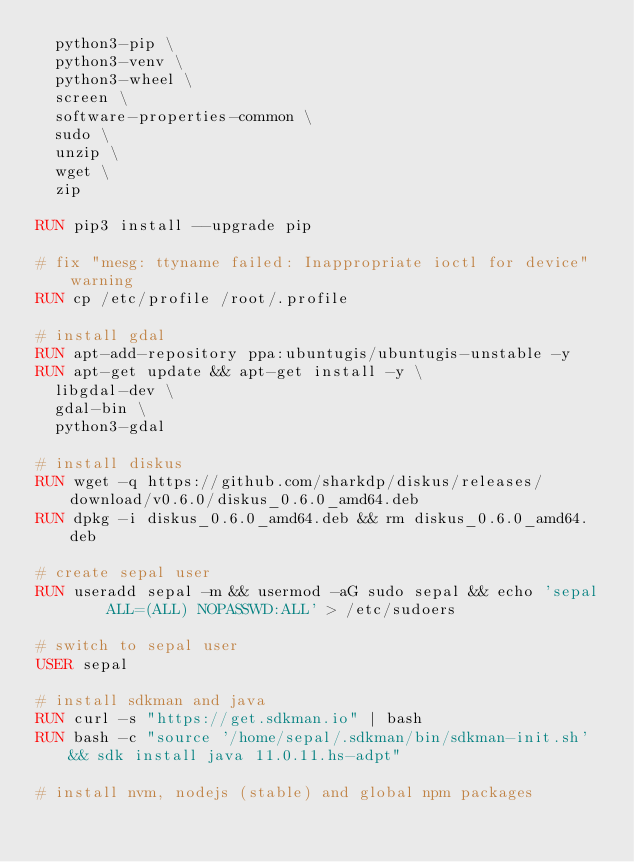Convert code to text. <code><loc_0><loc_0><loc_500><loc_500><_Dockerfile_>  python3-pip \
  python3-venv \
  python3-wheel \
  screen \
  software-properties-common \
  sudo \
  unzip \
  wget \
  zip

RUN pip3 install --upgrade pip

# fix "mesg: ttyname failed: Inappropriate ioctl for device" warning
RUN cp /etc/profile /root/.profile

# install gdal
RUN apt-add-repository ppa:ubuntugis/ubuntugis-unstable -y
RUN apt-get update && apt-get install -y \
  libgdal-dev \
  gdal-bin \
  python3-gdal

# install diskus
RUN wget -q https://github.com/sharkdp/diskus/releases/download/v0.6.0/diskus_0.6.0_amd64.deb
RUN dpkg -i diskus_0.6.0_amd64.deb && rm diskus_0.6.0_amd64.deb

# create sepal user
RUN useradd sepal -m && usermod -aG sudo sepal && echo 'sepal     ALL=(ALL) NOPASSWD:ALL' > /etc/sudoers

# switch to sepal user
USER sepal

# install sdkman and java
RUN curl -s "https://get.sdkman.io" | bash
RUN bash -c "source '/home/sepal/.sdkman/bin/sdkman-init.sh' && sdk install java 11.0.11.hs-adpt"

# install nvm, nodejs (stable) and global npm packages</code> 